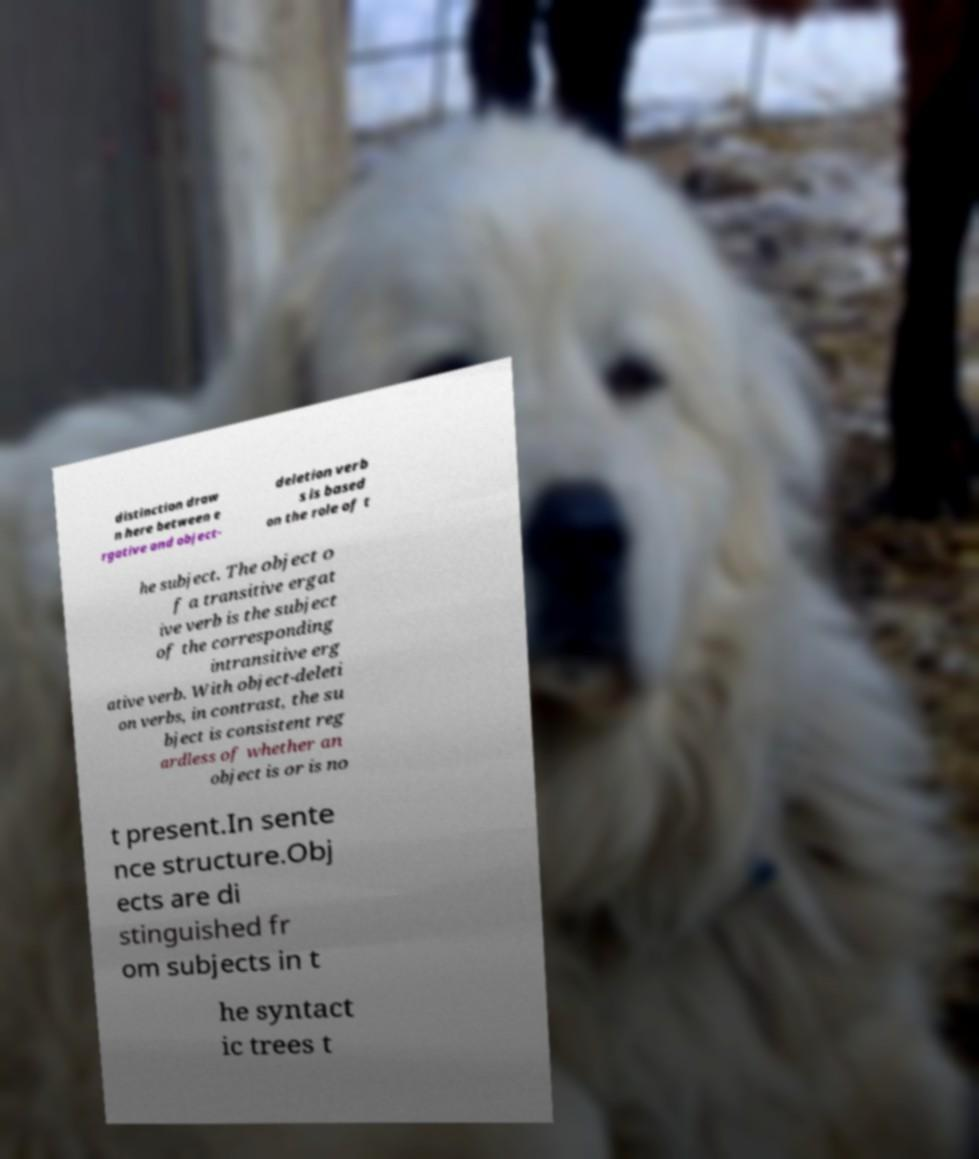What messages or text are displayed in this image? I need them in a readable, typed format. distinction draw n here between e rgative and object- deletion verb s is based on the role of t he subject. The object o f a transitive ergat ive verb is the subject of the corresponding intransitive erg ative verb. With object-deleti on verbs, in contrast, the su bject is consistent reg ardless of whether an object is or is no t present.In sente nce structure.Obj ects are di stinguished fr om subjects in t he syntact ic trees t 